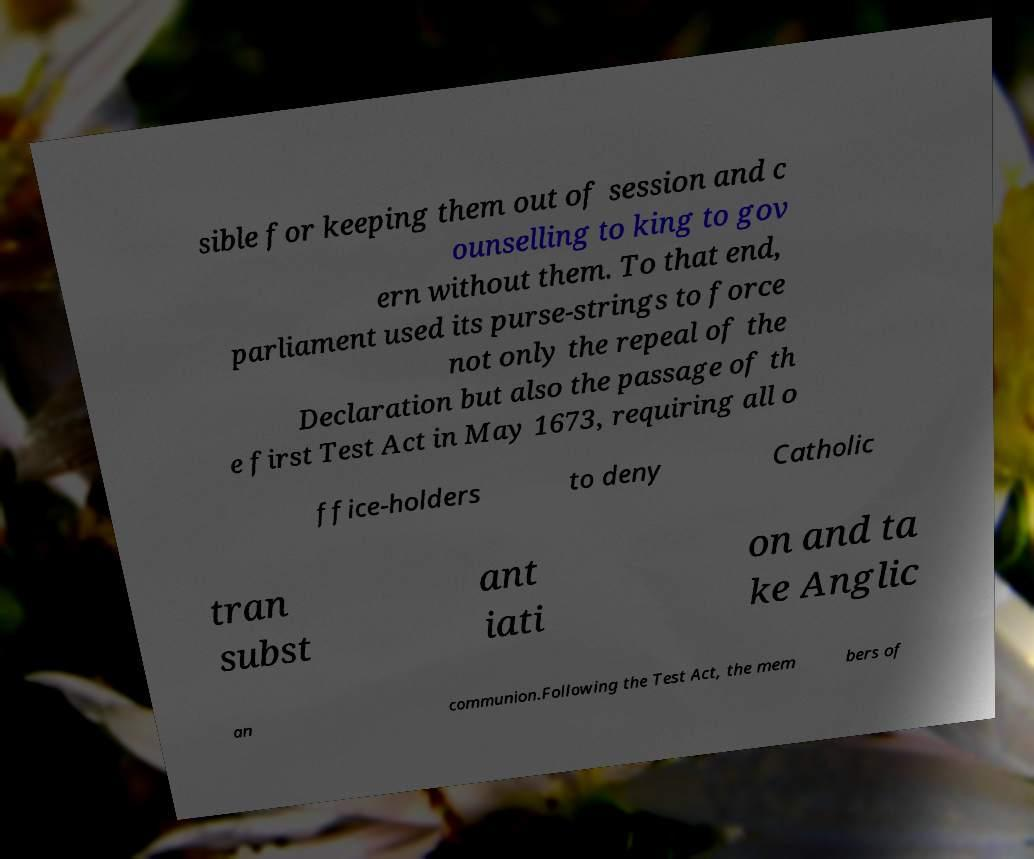Can you read and provide the text displayed in the image?This photo seems to have some interesting text. Can you extract and type it out for me? sible for keeping them out of session and c ounselling to king to gov ern without them. To that end, parliament used its purse-strings to force not only the repeal of the Declaration but also the passage of th e first Test Act in May 1673, requiring all o ffice-holders to deny Catholic tran subst ant iati on and ta ke Anglic an communion.Following the Test Act, the mem bers of 